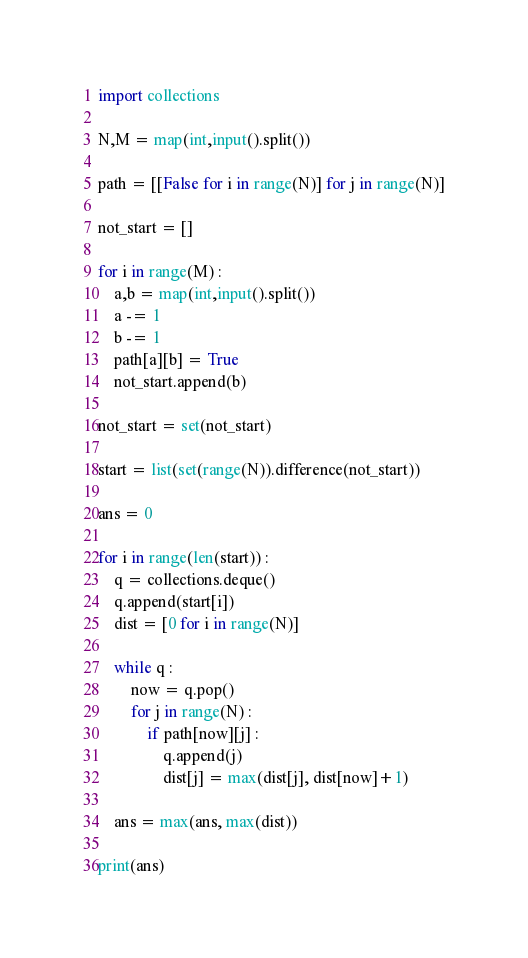<code> <loc_0><loc_0><loc_500><loc_500><_Python_>import collections

N,M = map(int,input().split())

path = [[False for i in range(N)] for j in range(N)]

not_start = []

for i in range(M) :
    a,b = map(int,input().split())
    a -= 1
    b -= 1
    path[a][b] = True
    not_start.append(b)

not_start = set(not_start)

start = list(set(range(N)).difference(not_start))

ans = 0

for i in range(len(start)) :
    q = collections.deque()
    q.append(start[i])
    dist = [0 for i in range(N)]
    
    while q :
        now = q.pop()
        for j in range(N) :
            if path[now][j] :
                q.append(j)
                dist[j] = max(dist[j], dist[now]+1)
    
    ans = max(ans, max(dist))

print(ans)

</code> 